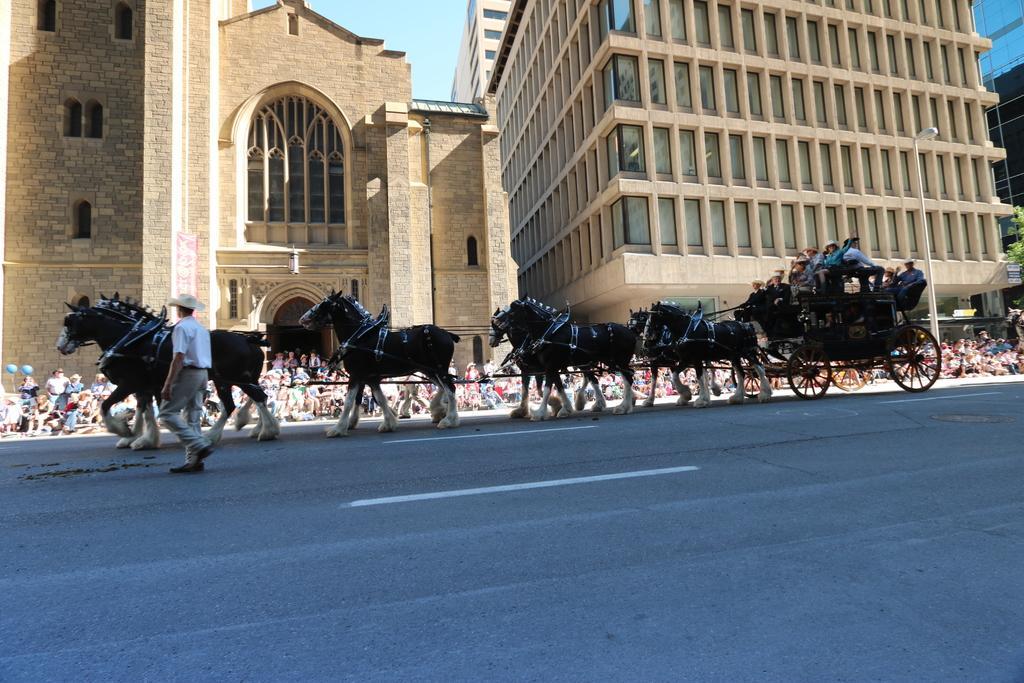Could you give a brief overview of what you see in this image? In this image we can see some horses and there is a tango in which there are some persons sitting and in the background of the image there are some persons sitting on ground and there are some buildings, clear sky. 